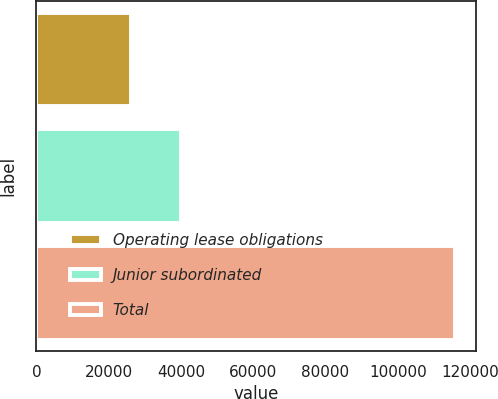<chart> <loc_0><loc_0><loc_500><loc_500><bar_chart><fcel>Operating lease obligations<fcel>Junior subordinated<fcel>Total<nl><fcel>26135<fcel>40061<fcel>115773<nl></chart> 